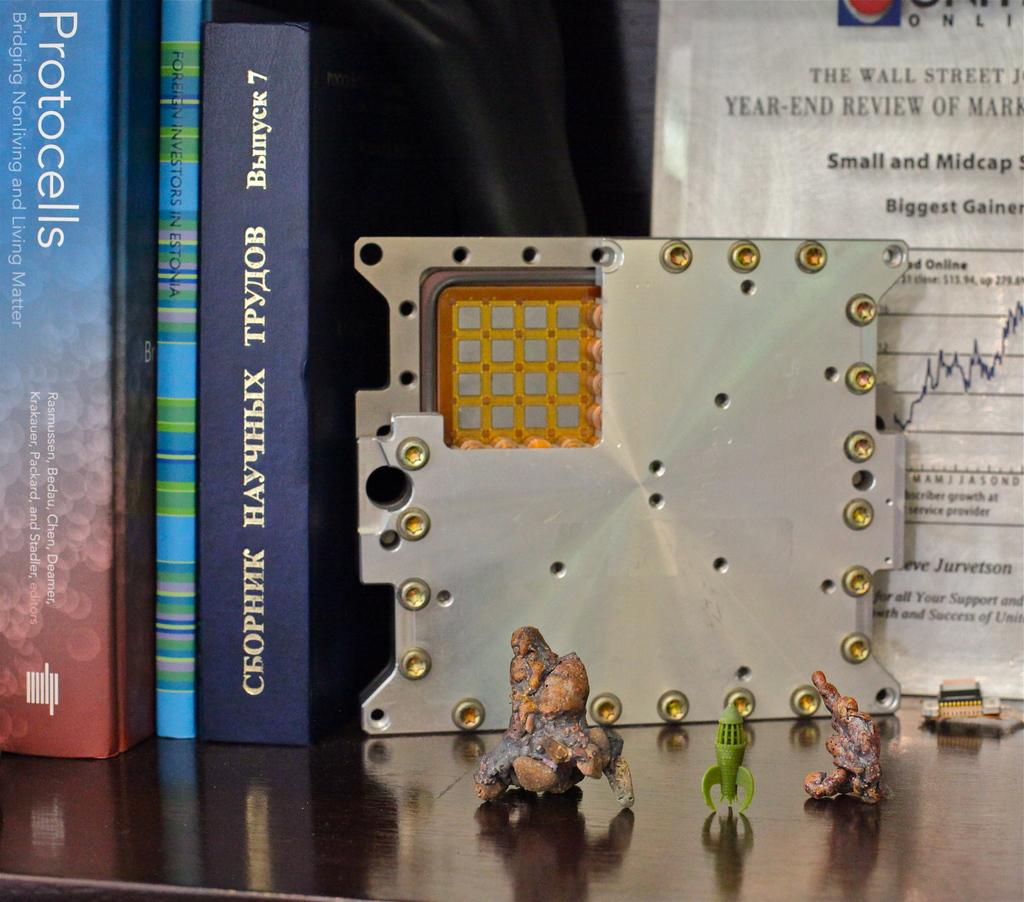Provide a one-sentence caption for the provided image. Several books are on a bookshelf. One of the books is titled Protocells. 